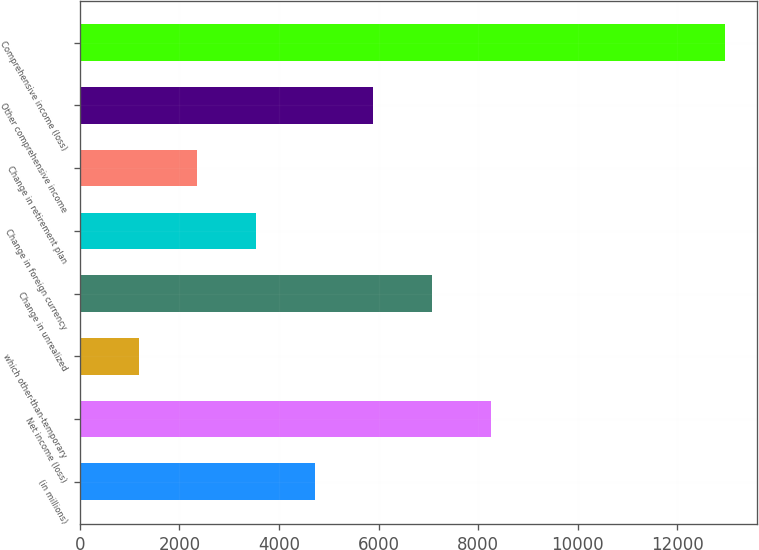Convert chart to OTSL. <chart><loc_0><loc_0><loc_500><loc_500><bar_chart><fcel>(in millions)<fcel>Net income (loss)<fcel>which other-than-temporary<fcel>Change in unrealized<fcel>Change in foreign currency<fcel>Change in retirement plan<fcel>Other comprehensive income<fcel>Comprehensive income (loss)<nl><fcel>4717.4<fcel>8251.7<fcel>1183.1<fcel>7073.6<fcel>3539.3<fcel>2361.2<fcel>5895.5<fcel>12959.1<nl></chart> 